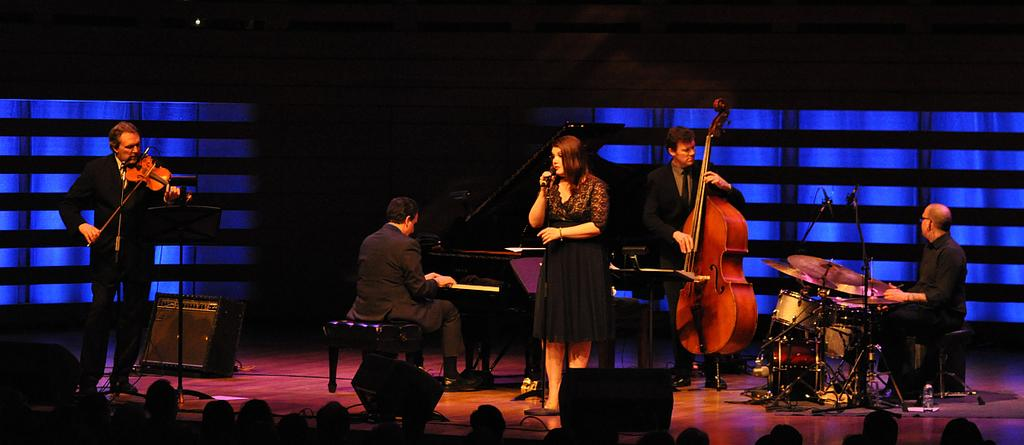What is happening on the stage in the image? There is an orchestra on the stage, and a girl is singing in the middle of the stage. What type of performance is taking place? The performance involves an orchestra and a girl singing, which suggests it is a musical performance. Can you describe the girl's position on the stage? The girl is singing in the middle of the stage. What color is the girl's sweater in the image? There is no information about the girl's sweater in the image, so we cannot determine its color. How does the girl start the performance in the image? The image does not show the beginning of the performance, so we cannot determine how the girl starts it. 